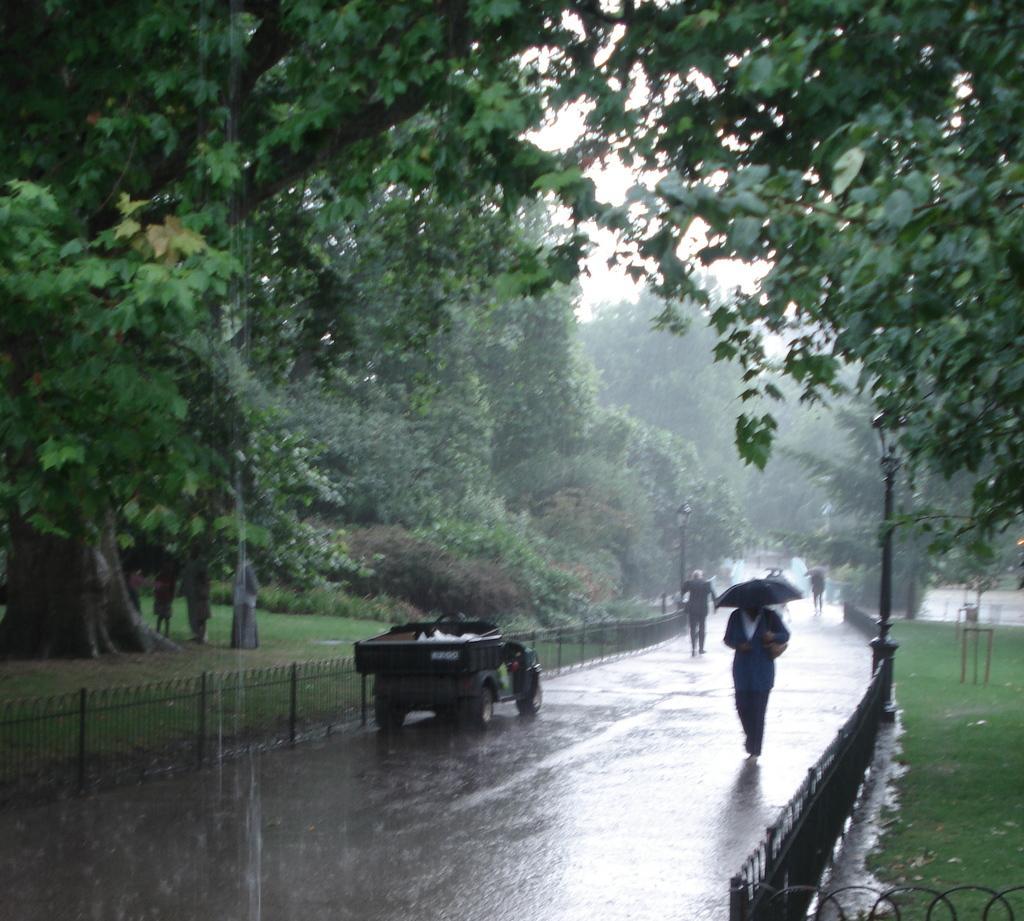Please provide a concise description of this image. In this image we can see some group of persons walking through the road holding umbrellas in their hands, there is vehicle, there is fencing and trees on left and right side of the image and top of the image there is clear sky. 